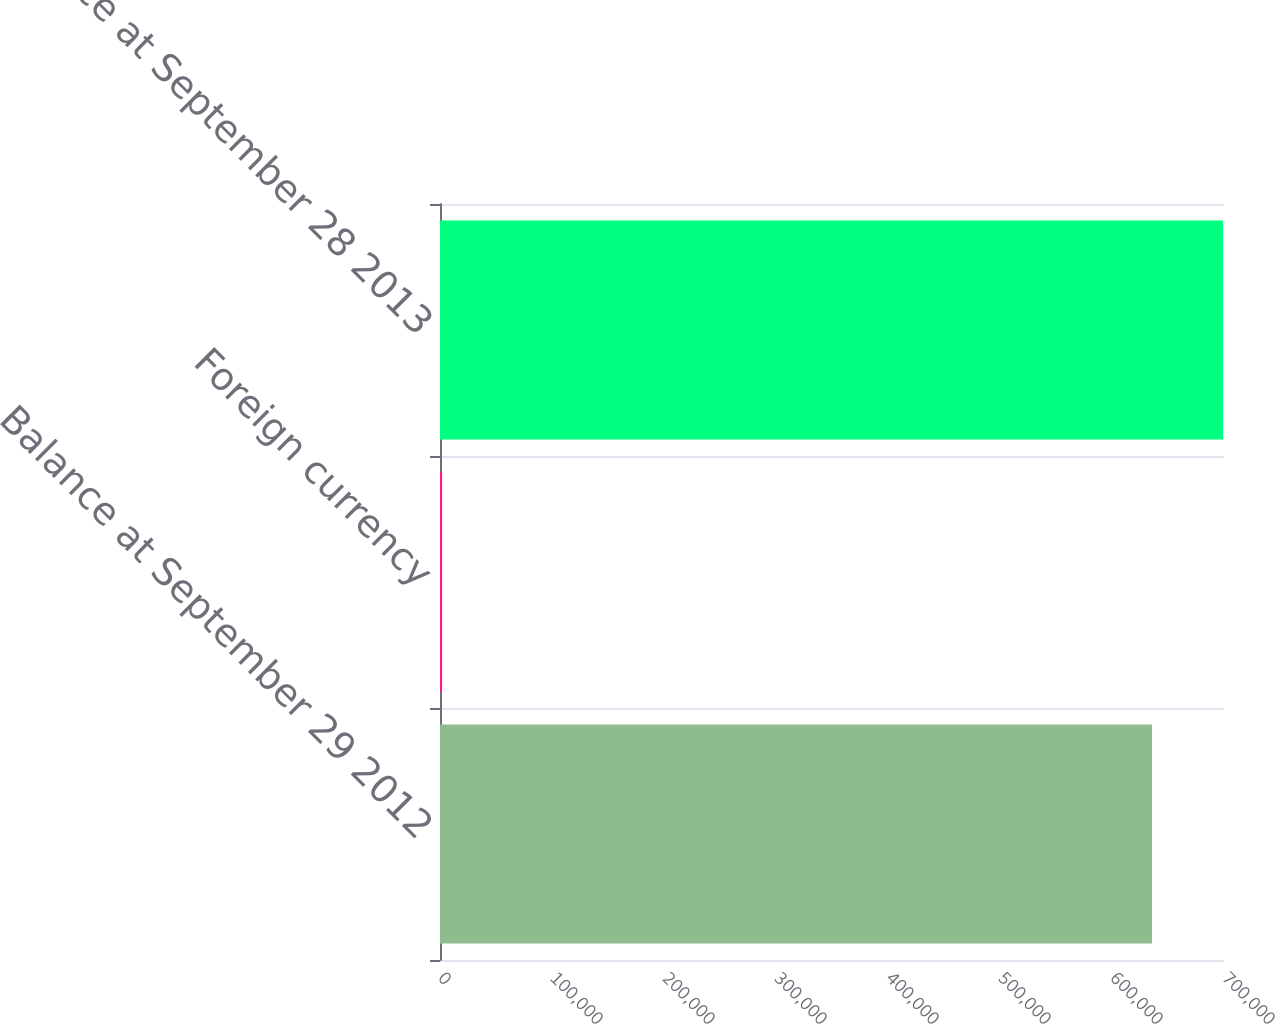Convert chart. <chart><loc_0><loc_0><loc_500><loc_500><bar_chart><fcel>Balance at September 29 2012<fcel>Foreign currency<fcel>Balance at September 28 2013<nl><fcel>635741<fcel>1866<fcel>699191<nl></chart> 